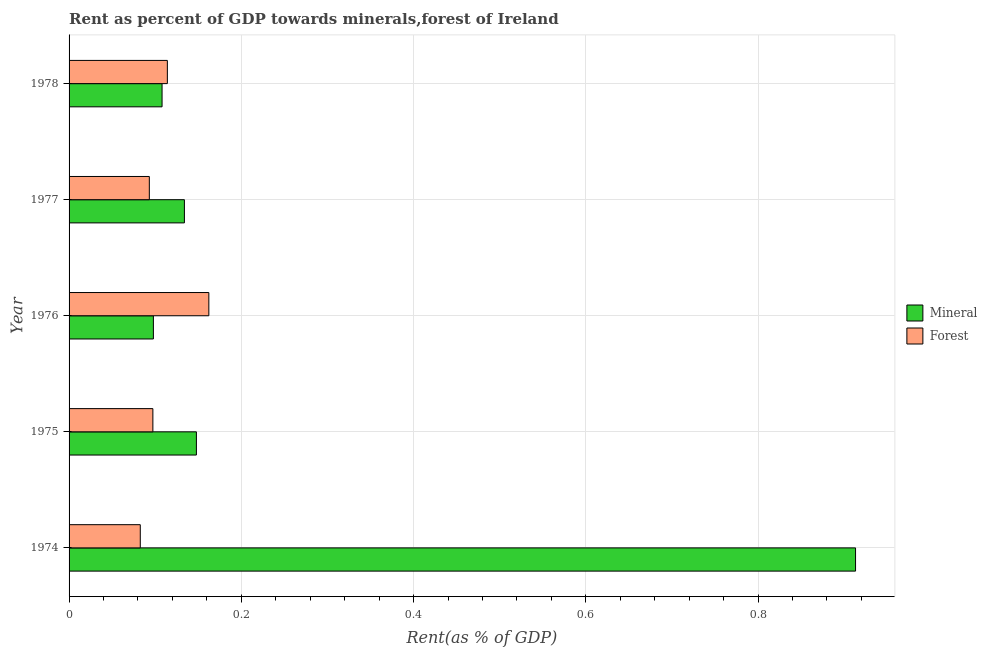Are the number of bars per tick equal to the number of legend labels?
Provide a succinct answer. Yes. Are the number of bars on each tick of the Y-axis equal?
Provide a succinct answer. Yes. How many bars are there on the 5th tick from the top?
Give a very brief answer. 2. How many bars are there on the 3rd tick from the bottom?
Ensure brevity in your answer.  2. What is the label of the 4th group of bars from the top?
Give a very brief answer. 1975. In how many cases, is the number of bars for a given year not equal to the number of legend labels?
Your response must be concise. 0. What is the mineral rent in 1977?
Your answer should be compact. 0.13. Across all years, what is the maximum forest rent?
Make the answer very short. 0.16. Across all years, what is the minimum forest rent?
Make the answer very short. 0.08. In which year was the mineral rent maximum?
Offer a terse response. 1974. In which year was the forest rent minimum?
Give a very brief answer. 1974. What is the total mineral rent in the graph?
Offer a terse response. 1.4. What is the difference between the forest rent in 1975 and that in 1977?
Keep it short and to the point. 0. What is the difference between the mineral rent in 1974 and the forest rent in 1976?
Your answer should be very brief. 0.75. What is the average mineral rent per year?
Offer a very short reply. 0.28. In the year 1975, what is the difference between the forest rent and mineral rent?
Your answer should be compact. -0.05. What is the ratio of the mineral rent in 1975 to that in 1976?
Your answer should be very brief. 1.51. What is the difference between the highest and the second highest forest rent?
Offer a terse response. 0.05. What is the difference between the highest and the lowest forest rent?
Offer a terse response. 0.08. In how many years, is the forest rent greater than the average forest rent taken over all years?
Provide a short and direct response. 2. What does the 1st bar from the top in 1977 represents?
Your response must be concise. Forest. What does the 1st bar from the bottom in 1978 represents?
Provide a short and direct response. Mineral. How many years are there in the graph?
Your answer should be compact. 5. Are the values on the major ticks of X-axis written in scientific E-notation?
Provide a succinct answer. No. Does the graph contain grids?
Offer a very short reply. Yes. How many legend labels are there?
Provide a short and direct response. 2. How are the legend labels stacked?
Provide a short and direct response. Vertical. What is the title of the graph?
Ensure brevity in your answer.  Rent as percent of GDP towards minerals,forest of Ireland. What is the label or title of the X-axis?
Ensure brevity in your answer.  Rent(as % of GDP). What is the Rent(as % of GDP) in Mineral in 1974?
Your answer should be very brief. 0.91. What is the Rent(as % of GDP) of Forest in 1974?
Make the answer very short. 0.08. What is the Rent(as % of GDP) of Mineral in 1975?
Give a very brief answer. 0.15. What is the Rent(as % of GDP) in Forest in 1975?
Your response must be concise. 0.1. What is the Rent(as % of GDP) of Mineral in 1976?
Ensure brevity in your answer.  0.1. What is the Rent(as % of GDP) of Forest in 1976?
Offer a terse response. 0.16. What is the Rent(as % of GDP) of Mineral in 1977?
Your answer should be compact. 0.13. What is the Rent(as % of GDP) of Forest in 1977?
Your answer should be compact. 0.09. What is the Rent(as % of GDP) in Mineral in 1978?
Your answer should be very brief. 0.11. What is the Rent(as % of GDP) of Forest in 1978?
Offer a very short reply. 0.11. Across all years, what is the maximum Rent(as % of GDP) of Mineral?
Your response must be concise. 0.91. Across all years, what is the maximum Rent(as % of GDP) of Forest?
Offer a terse response. 0.16. Across all years, what is the minimum Rent(as % of GDP) in Mineral?
Keep it short and to the point. 0.1. Across all years, what is the minimum Rent(as % of GDP) in Forest?
Offer a terse response. 0.08. What is the total Rent(as % of GDP) of Mineral in the graph?
Give a very brief answer. 1.4. What is the total Rent(as % of GDP) of Forest in the graph?
Your answer should be compact. 0.55. What is the difference between the Rent(as % of GDP) in Mineral in 1974 and that in 1975?
Your answer should be compact. 0.77. What is the difference between the Rent(as % of GDP) in Forest in 1974 and that in 1975?
Provide a succinct answer. -0.01. What is the difference between the Rent(as % of GDP) in Mineral in 1974 and that in 1976?
Your answer should be compact. 0.82. What is the difference between the Rent(as % of GDP) of Forest in 1974 and that in 1976?
Ensure brevity in your answer.  -0.08. What is the difference between the Rent(as % of GDP) of Mineral in 1974 and that in 1977?
Your response must be concise. 0.78. What is the difference between the Rent(as % of GDP) in Forest in 1974 and that in 1977?
Provide a succinct answer. -0.01. What is the difference between the Rent(as % of GDP) in Mineral in 1974 and that in 1978?
Your answer should be compact. 0.81. What is the difference between the Rent(as % of GDP) in Forest in 1974 and that in 1978?
Ensure brevity in your answer.  -0.03. What is the difference between the Rent(as % of GDP) in Mineral in 1975 and that in 1976?
Ensure brevity in your answer.  0.05. What is the difference between the Rent(as % of GDP) in Forest in 1975 and that in 1976?
Provide a succinct answer. -0.07. What is the difference between the Rent(as % of GDP) in Mineral in 1975 and that in 1977?
Your response must be concise. 0.01. What is the difference between the Rent(as % of GDP) in Forest in 1975 and that in 1977?
Your answer should be compact. 0. What is the difference between the Rent(as % of GDP) in Mineral in 1975 and that in 1978?
Offer a very short reply. 0.04. What is the difference between the Rent(as % of GDP) of Forest in 1975 and that in 1978?
Provide a succinct answer. -0.02. What is the difference between the Rent(as % of GDP) of Mineral in 1976 and that in 1977?
Give a very brief answer. -0.04. What is the difference between the Rent(as % of GDP) of Forest in 1976 and that in 1977?
Your answer should be compact. 0.07. What is the difference between the Rent(as % of GDP) in Mineral in 1976 and that in 1978?
Provide a short and direct response. -0.01. What is the difference between the Rent(as % of GDP) in Forest in 1976 and that in 1978?
Your answer should be compact. 0.05. What is the difference between the Rent(as % of GDP) of Mineral in 1977 and that in 1978?
Your answer should be very brief. 0.03. What is the difference between the Rent(as % of GDP) in Forest in 1977 and that in 1978?
Your response must be concise. -0.02. What is the difference between the Rent(as % of GDP) in Mineral in 1974 and the Rent(as % of GDP) in Forest in 1975?
Offer a very short reply. 0.82. What is the difference between the Rent(as % of GDP) of Mineral in 1974 and the Rent(as % of GDP) of Forest in 1976?
Your answer should be very brief. 0.75. What is the difference between the Rent(as % of GDP) in Mineral in 1974 and the Rent(as % of GDP) in Forest in 1977?
Give a very brief answer. 0.82. What is the difference between the Rent(as % of GDP) of Mineral in 1974 and the Rent(as % of GDP) of Forest in 1978?
Ensure brevity in your answer.  0.8. What is the difference between the Rent(as % of GDP) of Mineral in 1975 and the Rent(as % of GDP) of Forest in 1976?
Give a very brief answer. -0.01. What is the difference between the Rent(as % of GDP) in Mineral in 1975 and the Rent(as % of GDP) in Forest in 1977?
Provide a short and direct response. 0.05. What is the difference between the Rent(as % of GDP) in Mineral in 1975 and the Rent(as % of GDP) in Forest in 1978?
Make the answer very short. 0.03. What is the difference between the Rent(as % of GDP) of Mineral in 1976 and the Rent(as % of GDP) of Forest in 1977?
Ensure brevity in your answer.  0. What is the difference between the Rent(as % of GDP) of Mineral in 1976 and the Rent(as % of GDP) of Forest in 1978?
Your answer should be very brief. -0.02. What is the difference between the Rent(as % of GDP) of Mineral in 1977 and the Rent(as % of GDP) of Forest in 1978?
Ensure brevity in your answer.  0.02. What is the average Rent(as % of GDP) of Mineral per year?
Keep it short and to the point. 0.28. What is the average Rent(as % of GDP) of Forest per year?
Your answer should be compact. 0.11. In the year 1974, what is the difference between the Rent(as % of GDP) in Mineral and Rent(as % of GDP) in Forest?
Provide a succinct answer. 0.83. In the year 1975, what is the difference between the Rent(as % of GDP) of Mineral and Rent(as % of GDP) of Forest?
Provide a short and direct response. 0.05. In the year 1976, what is the difference between the Rent(as % of GDP) in Mineral and Rent(as % of GDP) in Forest?
Offer a very short reply. -0.06. In the year 1977, what is the difference between the Rent(as % of GDP) of Mineral and Rent(as % of GDP) of Forest?
Give a very brief answer. 0.04. In the year 1978, what is the difference between the Rent(as % of GDP) of Mineral and Rent(as % of GDP) of Forest?
Give a very brief answer. -0.01. What is the ratio of the Rent(as % of GDP) in Mineral in 1974 to that in 1975?
Provide a succinct answer. 6.18. What is the ratio of the Rent(as % of GDP) in Forest in 1974 to that in 1975?
Offer a very short reply. 0.85. What is the ratio of the Rent(as % of GDP) in Mineral in 1974 to that in 1976?
Provide a succinct answer. 9.33. What is the ratio of the Rent(as % of GDP) in Forest in 1974 to that in 1976?
Your answer should be compact. 0.51. What is the ratio of the Rent(as % of GDP) of Mineral in 1974 to that in 1977?
Give a very brief answer. 6.82. What is the ratio of the Rent(as % of GDP) in Forest in 1974 to that in 1977?
Your answer should be very brief. 0.89. What is the ratio of the Rent(as % of GDP) of Mineral in 1974 to that in 1978?
Your response must be concise. 8.46. What is the ratio of the Rent(as % of GDP) in Forest in 1974 to that in 1978?
Keep it short and to the point. 0.72. What is the ratio of the Rent(as % of GDP) in Mineral in 1975 to that in 1976?
Your answer should be compact. 1.51. What is the ratio of the Rent(as % of GDP) of Forest in 1975 to that in 1976?
Ensure brevity in your answer.  0.6. What is the ratio of the Rent(as % of GDP) in Mineral in 1975 to that in 1977?
Your response must be concise. 1.1. What is the ratio of the Rent(as % of GDP) in Forest in 1975 to that in 1977?
Offer a terse response. 1.04. What is the ratio of the Rent(as % of GDP) in Mineral in 1975 to that in 1978?
Your response must be concise. 1.37. What is the ratio of the Rent(as % of GDP) in Forest in 1975 to that in 1978?
Keep it short and to the point. 0.85. What is the ratio of the Rent(as % of GDP) in Mineral in 1976 to that in 1977?
Offer a terse response. 0.73. What is the ratio of the Rent(as % of GDP) in Forest in 1976 to that in 1977?
Give a very brief answer. 1.74. What is the ratio of the Rent(as % of GDP) in Mineral in 1976 to that in 1978?
Your response must be concise. 0.91. What is the ratio of the Rent(as % of GDP) in Forest in 1976 to that in 1978?
Keep it short and to the point. 1.42. What is the ratio of the Rent(as % of GDP) of Mineral in 1977 to that in 1978?
Provide a succinct answer. 1.24. What is the ratio of the Rent(as % of GDP) in Forest in 1977 to that in 1978?
Provide a succinct answer. 0.82. What is the difference between the highest and the second highest Rent(as % of GDP) in Mineral?
Your answer should be very brief. 0.77. What is the difference between the highest and the second highest Rent(as % of GDP) of Forest?
Offer a very short reply. 0.05. What is the difference between the highest and the lowest Rent(as % of GDP) in Mineral?
Your answer should be very brief. 0.82. What is the difference between the highest and the lowest Rent(as % of GDP) in Forest?
Ensure brevity in your answer.  0.08. 